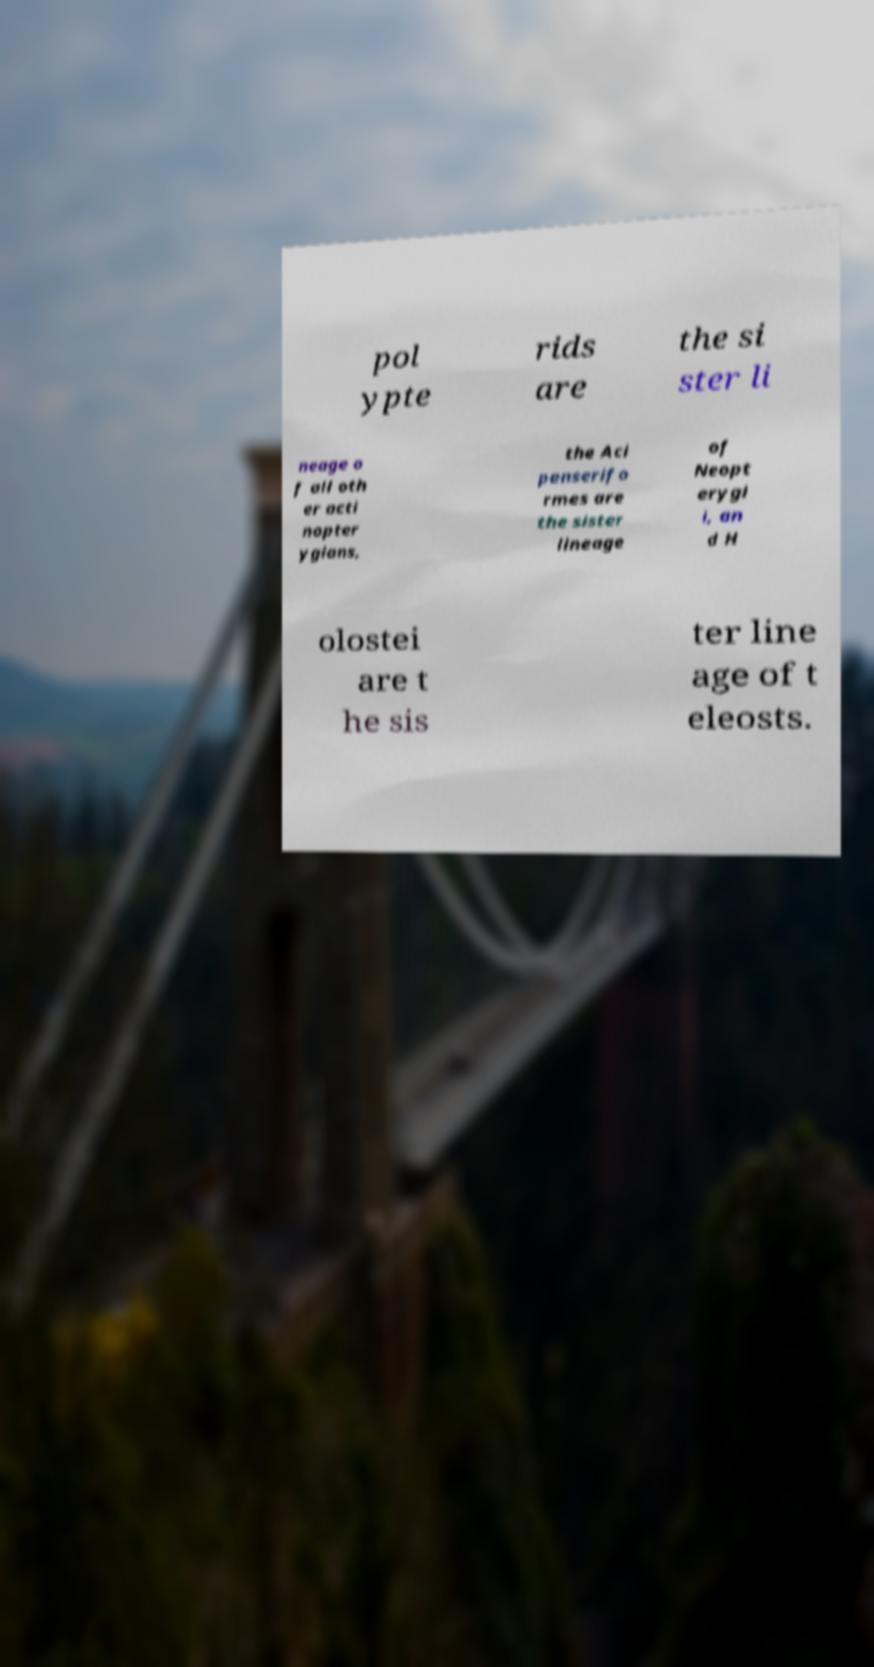Could you extract and type out the text from this image? pol ypte rids are the si ster li neage o f all oth er acti nopter ygians, the Aci penserifo rmes are the sister lineage of Neopt erygi i, an d H olostei are t he sis ter line age of t eleosts. 